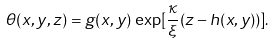<formula> <loc_0><loc_0><loc_500><loc_500>\theta ( x , y , z ) = g ( x , y ) \, \exp [ \frac { \kappa } { \xi } ( z - h ( x , y ) ) ] .</formula> 